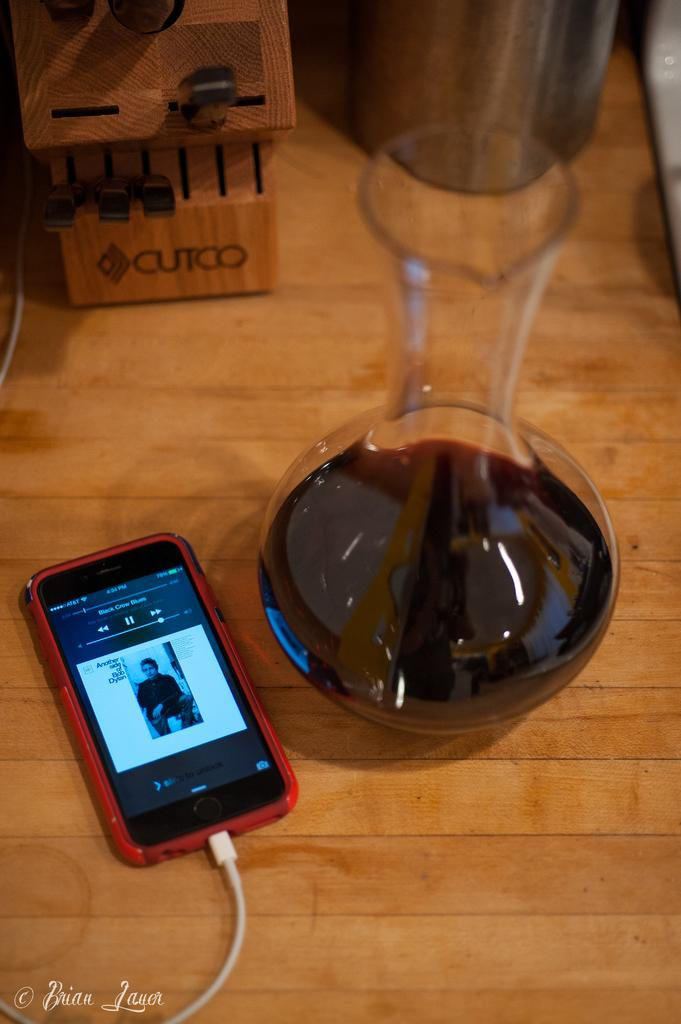Provide a one-sentence caption for the provided image. A phone with Black Crows Blues song on playscreen sitting next to wine caref. 